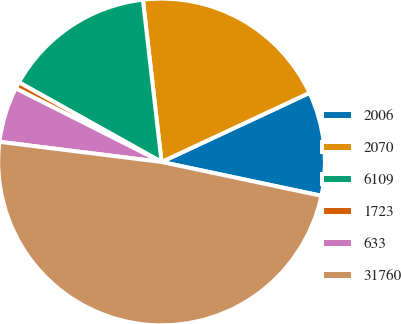Convert chart to OTSL. <chart><loc_0><loc_0><loc_500><loc_500><pie_chart><fcel>2006<fcel>2070<fcel>6109<fcel>1723<fcel>633<fcel>31760<nl><fcel>10.27%<fcel>19.87%<fcel>15.07%<fcel>0.67%<fcel>5.47%<fcel>48.65%<nl></chart> 